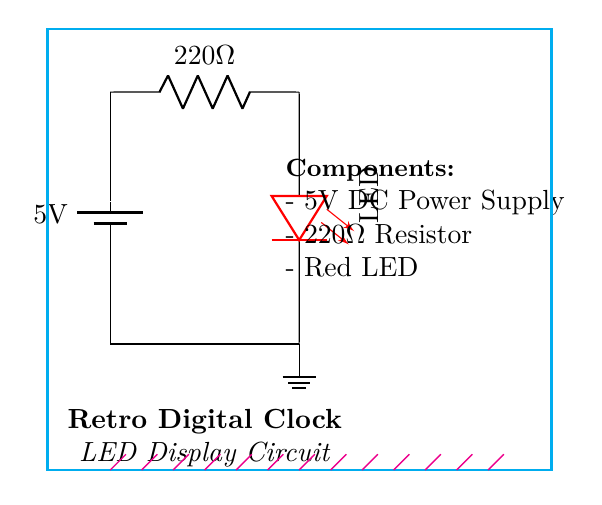What is the voltage of this circuit? The voltage is 5V, which is indicated by the label on the battery in the circuit diagram.
Answer: 5V What is the value of the resistor in this circuit? The resistor is labeled as 220 ohms in the circuit diagram, which shows its value clearly.
Answer: 220 ohms How many components are in this circuit? There are three main components: the battery, the resistor, and the LED, which are all visible in the diagram.
Answer: Three What does the LED represent in the circuit? The LED, indicated as a red light-emitting diode in the circuit, serves as the visual output for the digital clock display.
Answer: Visual output Explain the function of the resistor in this circuit. The resistor limits the current flowing through the LED, preventing it from drawing too much current and getting damaged. This circuit ensures appropriate current is supplied to the LED.
Answer: Current limiting What would happen if the resistor value were much lower than 220 ohms? A significantly lower resistor value would allow too much current to flow through the LED, likely leading to its burnout due to overheating. It is essential to maintain the resistor value to ensure LED safety.
Answer: LED burnout What is the purpose of the 5V power supply in this circuit? The 5V power supply provides the necessary voltage for the circuit to function, allowing enough potential difference for the LED to light up while also powering the other components.
Answer: Power source 